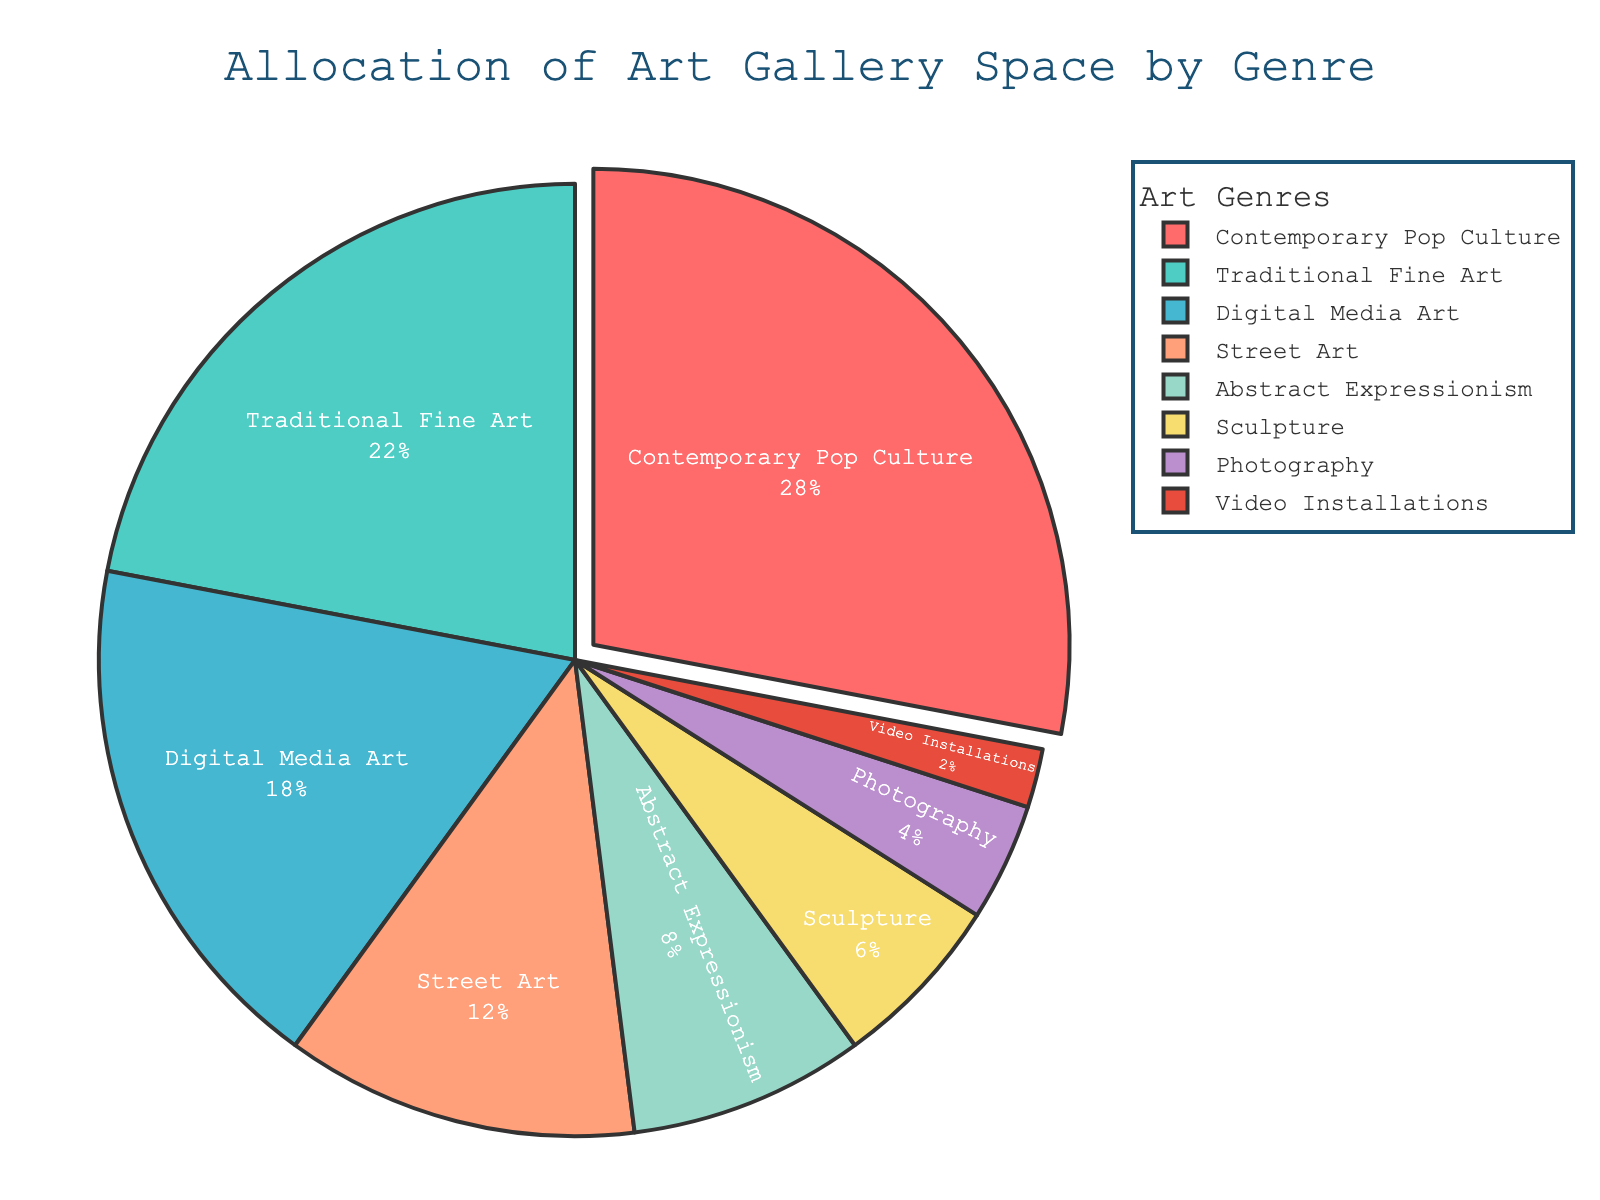What genre occupies the largest percentage of gallery space? The genre occupying the largest percentage of gallery space is identified by the largest slice of the pie chart. Here, the "Contemporary Pop Culture" genre has the largest slice at 28%.
Answer: Contemporary Pop Culture What is the combined percentage of gallery space allocated to Street Art and Abstract Expressionism? To find the combined percentage, add the given percentages for Street Art (12%) and Abstract Expressionism (8%). So, 12% + 8% = 20%.
Answer: 20% How does the percentage of gallery space for Digital Media Art compare to Traditional Fine Art? Compare the slices labeled "Digital Media Art" (18%) and "Traditional Fine Art" (22%). The Traditional Fine Art genre has a higher percentage than Digital Media Art by 4%.
Answer: Traditional Fine Art is 4% more Which genre occupies the smallest percentage of gallery space? The genre occupying the smallest percentage is identified by the smallest slice. "Video Installations" has the smallest slice at 2%.
Answer: Video Installations What is the total percentage allocated to genres influenced by contemporary trends (Contemporary Pop Culture, Digital Media Art, and Street Art)? Sum the percentages of Contemporary Pop Culture (28%), Digital Media Art (18%), and Street Art (12%). So, 28% + 18% + 12% = 58%.
Answer: 58% Which genre occupies more space: Sculpture or Photography? Compare the slices for "Sculpture" (6%) and "Photography" (4%). Sculpture has a larger percentage.
Answer: Sculpture What is the difference between the space allocated to Abstract Expressionism and that of Video Installations? Subtract the percentage of Video Installations (2%) from Abstract Expressionism (8%). So, 8% - 2% = 6%.
Answer: 6% If the gallery space for Contemporary Pop Culture was reduced by 5%, how much space would it then occupy? Subtract 5% from the Contemporary Pop Culture allocation of 28%. So, 28% - 5% = 23%.
Answer: 23% What is the average percentage allocation for the genres Digital Media Art, Street Art, and Abstract Expressionism? Sum the percentages of Digital Media Art (18%), Street Art (12%), and Abstract Expressionism (8%), and then divide by 3. So, (18% + 12% + 8%) / 3 = 38% / 3 ≈ 12.67%.
Answer: Approximately 12.67% Which genre(s) have a percentage allocation smaller than 10%? Identify slices with less than 10%: Abstract Expressionism (8%), Sculpture (6%), Photography (4%), and Video Installations (2%).
Answer: Abstract Expressionism, Sculpture, Photography, Video Installations 